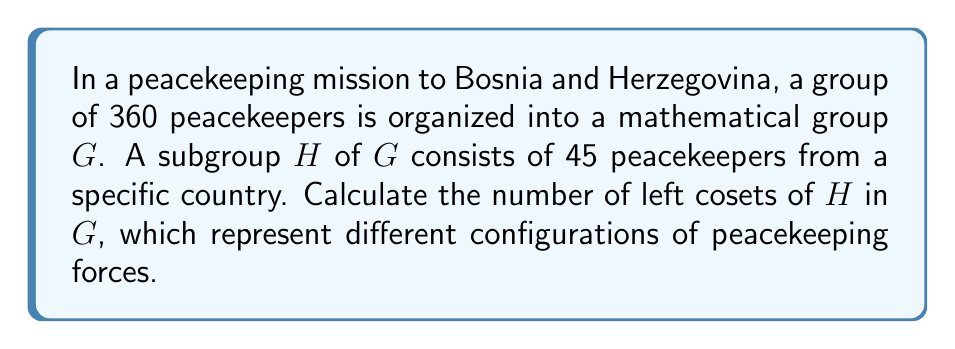Show me your answer to this math problem. To solve this problem, we'll use the following steps:

1) Recall the Lagrange's Theorem: For a finite group $G$ and a subgroup $H$ of $G$, the order of $H$ divides the order of $G$. Moreover, the number of left cosets of $H$ in $G$ is equal to the index of $H$ in $G$, denoted as $[G:H]$.

2) The index $[G:H]$ is calculated by dividing the order of $G$ by the order of $H$:

   $$[G:H] = \frac{|G|}{|H|}$$

3) In this case:
   $|G| = 360$ (total number of peacekeepers)
   $|H| = 45$ (number of peacekeepers in the subgroup)

4) Substituting these values:

   $$[G:H] = \frac{360}{45}$$

5) Simplify:
   $$[G:H] = 8$$

6) Therefore, there are 8 left cosets of $H$ in $G$.

This result indicates that the peacekeeping force can be divided into 8 distinct configurations based on the subgroup $H$, potentially representing different operational units or rotations in the peacekeeping mission.
Answer: The number of left cosets of $H$ in $G$ is 8. 